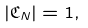Convert formula to latex. <formula><loc_0><loc_0><loc_500><loc_500>| \mathfrak { C } _ { N } | = 1 ,</formula> 